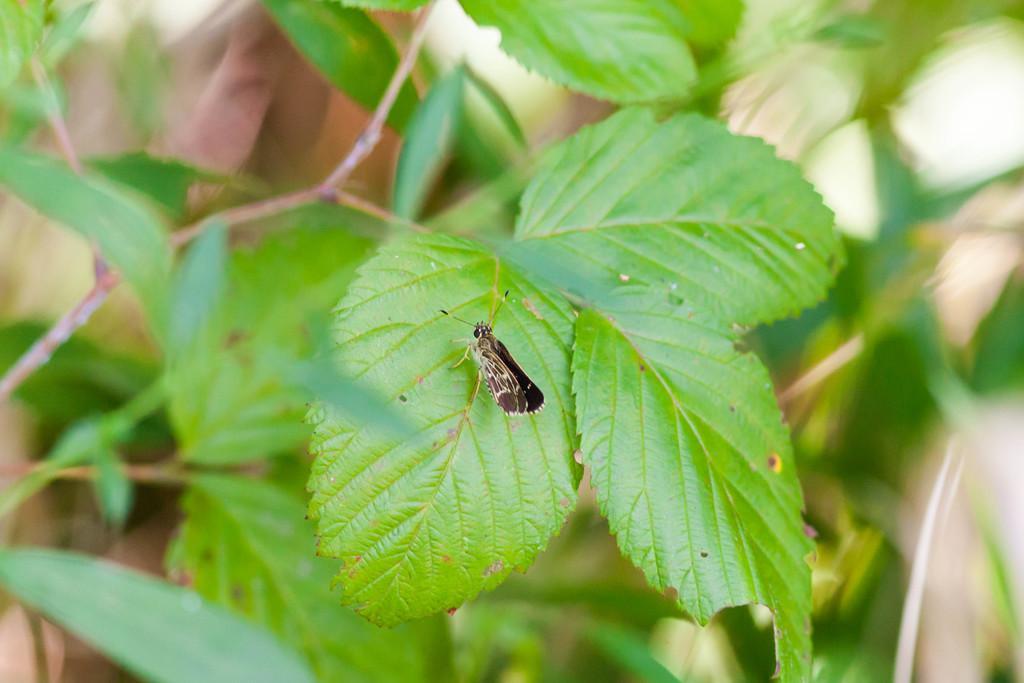How would you summarize this image in a sentence or two? In this picture there is a plant. In the center of the picture there is an insect. 